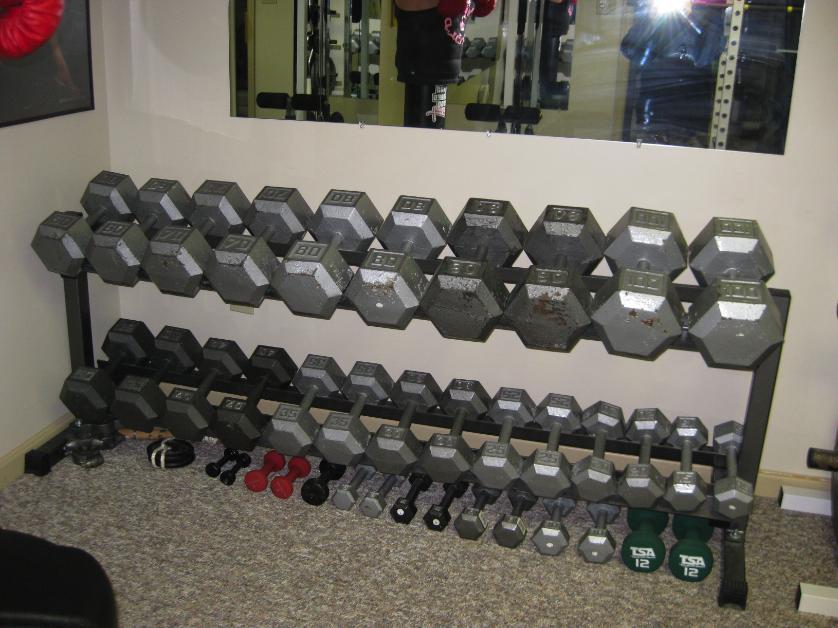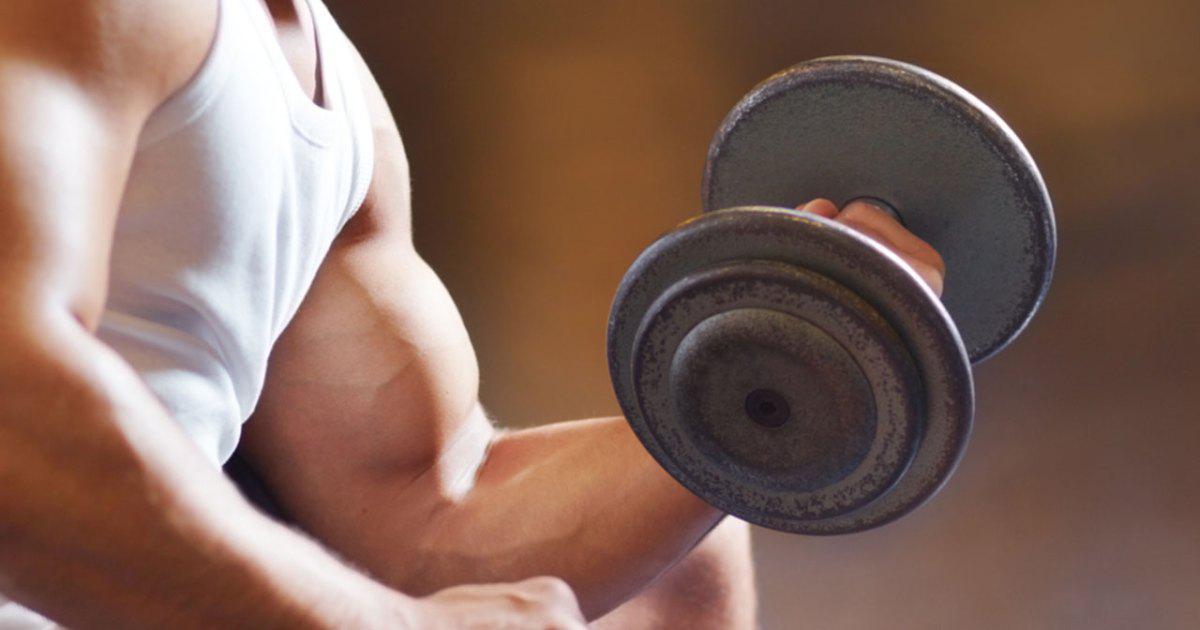The first image is the image on the left, the second image is the image on the right. Evaluate the accuracy of this statement regarding the images: "In the image on the left, at least 8 dumbbells are stored against a wall sitting in a straight line.". Is it true? Answer yes or no. Yes. The first image is the image on the left, the second image is the image on the right. Considering the images on both sides, is "In at least one image there is a person sitting and working out with weights." valid? Answer yes or no. Yes. 